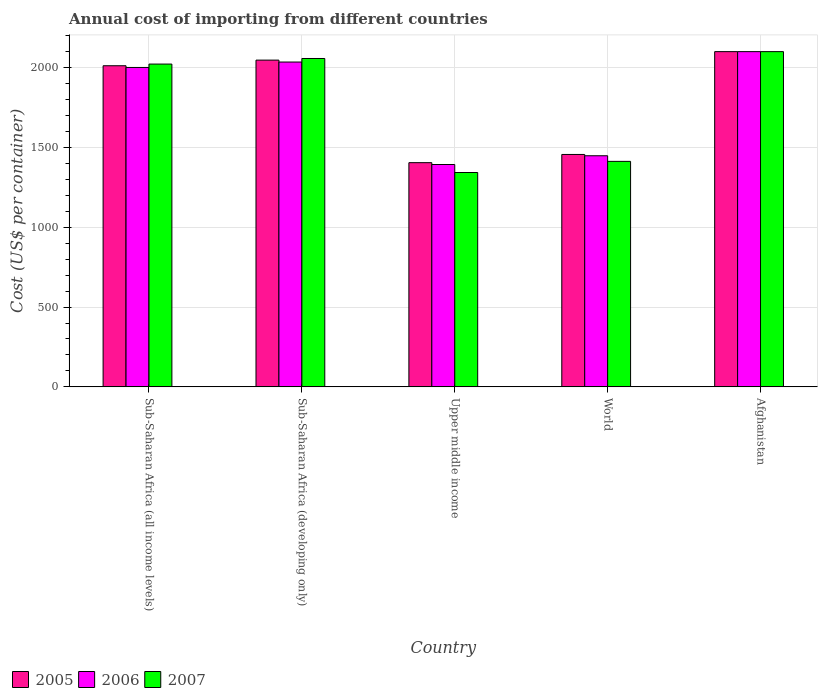How many different coloured bars are there?
Provide a succinct answer. 3. How many groups of bars are there?
Keep it short and to the point. 5. How many bars are there on the 3rd tick from the left?
Offer a terse response. 3. How many bars are there on the 3rd tick from the right?
Your answer should be very brief. 3. What is the label of the 4th group of bars from the left?
Provide a succinct answer. World. In how many cases, is the number of bars for a given country not equal to the number of legend labels?
Offer a very short reply. 0. What is the total annual cost of importing in 2006 in Afghanistan?
Provide a short and direct response. 2100. Across all countries, what is the maximum total annual cost of importing in 2007?
Your response must be concise. 2100. Across all countries, what is the minimum total annual cost of importing in 2007?
Make the answer very short. 1342.85. In which country was the total annual cost of importing in 2007 maximum?
Offer a very short reply. Afghanistan. In which country was the total annual cost of importing in 2007 minimum?
Your answer should be compact. Upper middle income. What is the total total annual cost of importing in 2005 in the graph?
Your answer should be compact. 9018.91. What is the difference between the total annual cost of importing in 2006 in Sub-Saharan Africa (all income levels) and that in World?
Provide a short and direct response. 553.13. What is the difference between the total annual cost of importing in 2007 in World and the total annual cost of importing in 2005 in Sub-Saharan Africa (all income levels)?
Offer a terse response. -599.03. What is the average total annual cost of importing in 2006 per country?
Ensure brevity in your answer.  1795.28. What is the difference between the total annual cost of importing of/in 2007 and total annual cost of importing of/in 2005 in Sub-Saharan Africa (developing only)?
Your response must be concise. 10.16. What is the ratio of the total annual cost of importing in 2007 in Sub-Saharan Africa (developing only) to that in World?
Offer a terse response. 1.46. Is the total annual cost of importing in 2007 in Sub-Saharan Africa (developing only) less than that in World?
Provide a succinct answer. No. Is the difference between the total annual cost of importing in 2007 in Sub-Saharan Africa (all income levels) and Upper middle income greater than the difference between the total annual cost of importing in 2005 in Sub-Saharan Africa (all income levels) and Upper middle income?
Keep it short and to the point. Yes. What is the difference between the highest and the second highest total annual cost of importing in 2007?
Keep it short and to the point. -42.93. What is the difference between the highest and the lowest total annual cost of importing in 2005?
Make the answer very short. 695.49. Is the sum of the total annual cost of importing in 2005 in Afghanistan and Sub-Saharan Africa (all income levels) greater than the maximum total annual cost of importing in 2007 across all countries?
Your answer should be very brief. Yes. What does the 2nd bar from the right in Upper middle income represents?
Ensure brevity in your answer.  2006. How many bars are there?
Provide a short and direct response. 15. Are all the bars in the graph horizontal?
Your answer should be very brief. No. Does the graph contain grids?
Offer a terse response. Yes. Where does the legend appear in the graph?
Give a very brief answer. Bottom left. How many legend labels are there?
Make the answer very short. 3. How are the legend labels stacked?
Your answer should be very brief. Horizontal. What is the title of the graph?
Your answer should be very brief. Annual cost of importing from different countries. Does "2007" appear as one of the legend labels in the graph?
Your answer should be compact. Yes. What is the label or title of the Y-axis?
Offer a terse response. Cost (US$ per container). What is the Cost (US$ per container) of 2005 in Sub-Saharan Africa (all income levels)?
Your answer should be very brief. 2011.64. What is the Cost (US$ per container) of 2006 in Sub-Saharan Africa (all income levels)?
Your answer should be very brief. 2000.87. What is the Cost (US$ per container) in 2007 in Sub-Saharan Africa (all income levels)?
Make the answer very short. 2022.13. What is the Cost (US$ per container) in 2005 in Sub-Saharan Africa (developing only)?
Offer a very short reply. 2046.91. What is the Cost (US$ per container) of 2006 in Sub-Saharan Africa (developing only)?
Ensure brevity in your answer.  2034.84. What is the Cost (US$ per container) of 2007 in Sub-Saharan Africa (developing only)?
Make the answer very short. 2057.07. What is the Cost (US$ per container) of 2005 in Upper middle income?
Keep it short and to the point. 1404.51. What is the Cost (US$ per container) in 2006 in Upper middle income?
Keep it short and to the point. 1392.96. What is the Cost (US$ per container) in 2007 in Upper middle income?
Your answer should be compact. 1342.85. What is the Cost (US$ per container) in 2005 in World?
Keep it short and to the point. 1455.85. What is the Cost (US$ per container) in 2006 in World?
Provide a short and direct response. 1447.74. What is the Cost (US$ per container) in 2007 in World?
Keep it short and to the point. 1412.62. What is the Cost (US$ per container) in 2005 in Afghanistan?
Offer a terse response. 2100. What is the Cost (US$ per container) in 2006 in Afghanistan?
Offer a very short reply. 2100. What is the Cost (US$ per container) in 2007 in Afghanistan?
Your answer should be very brief. 2100. Across all countries, what is the maximum Cost (US$ per container) in 2005?
Offer a terse response. 2100. Across all countries, what is the maximum Cost (US$ per container) of 2006?
Keep it short and to the point. 2100. Across all countries, what is the maximum Cost (US$ per container) in 2007?
Make the answer very short. 2100. Across all countries, what is the minimum Cost (US$ per container) in 2005?
Provide a succinct answer. 1404.51. Across all countries, what is the minimum Cost (US$ per container) in 2006?
Ensure brevity in your answer.  1392.96. Across all countries, what is the minimum Cost (US$ per container) of 2007?
Your answer should be very brief. 1342.85. What is the total Cost (US$ per container) in 2005 in the graph?
Keep it short and to the point. 9018.91. What is the total Cost (US$ per container) of 2006 in the graph?
Your answer should be compact. 8976.41. What is the total Cost (US$ per container) in 2007 in the graph?
Your answer should be compact. 8934.67. What is the difference between the Cost (US$ per container) of 2005 in Sub-Saharan Africa (all income levels) and that in Sub-Saharan Africa (developing only)?
Your answer should be compact. -35.26. What is the difference between the Cost (US$ per container) in 2006 in Sub-Saharan Africa (all income levels) and that in Sub-Saharan Africa (developing only)?
Your answer should be very brief. -33.97. What is the difference between the Cost (US$ per container) of 2007 in Sub-Saharan Africa (all income levels) and that in Sub-Saharan Africa (developing only)?
Keep it short and to the point. -34.94. What is the difference between the Cost (US$ per container) in 2005 in Sub-Saharan Africa (all income levels) and that in Upper middle income?
Provide a succinct answer. 607.13. What is the difference between the Cost (US$ per container) in 2006 in Sub-Saharan Africa (all income levels) and that in Upper middle income?
Your answer should be very brief. 607.91. What is the difference between the Cost (US$ per container) of 2007 in Sub-Saharan Africa (all income levels) and that in Upper middle income?
Your answer should be compact. 679.28. What is the difference between the Cost (US$ per container) in 2005 in Sub-Saharan Africa (all income levels) and that in World?
Your answer should be compact. 555.79. What is the difference between the Cost (US$ per container) in 2006 in Sub-Saharan Africa (all income levels) and that in World?
Provide a short and direct response. 553.13. What is the difference between the Cost (US$ per container) of 2007 in Sub-Saharan Africa (all income levels) and that in World?
Your answer should be very brief. 609.51. What is the difference between the Cost (US$ per container) in 2005 in Sub-Saharan Africa (all income levels) and that in Afghanistan?
Provide a short and direct response. -88.36. What is the difference between the Cost (US$ per container) in 2006 in Sub-Saharan Africa (all income levels) and that in Afghanistan?
Offer a very short reply. -99.13. What is the difference between the Cost (US$ per container) of 2007 in Sub-Saharan Africa (all income levels) and that in Afghanistan?
Provide a short and direct response. -77.87. What is the difference between the Cost (US$ per container) in 2005 in Sub-Saharan Africa (developing only) and that in Upper middle income?
Your answer should be compact. 642.4. What is the difference between the Cost (US$ per container) of 2006 in Sub-Saharan Africa (developing only) and that in Upper middle income?
Make the answer very short. 641.88. What is the difference between the Cost (US$ per container) in 2007 in Sub-Saharan Africa (developing only) and that in Upper middle income?
Make the answer very short. 714.21. What is the difference between the Cost (US$ per container) in 2005 in Sub-Saharan Africa (developing only) and that in World?
Provide a short and direct response. 591.06. What is the difference between the Cost (US$ per container) in 2006 in Sub-Saharan Africa (developing only) and that in World?
Your answer should be compact. 587.1. What is the difference between the Cost (US$ per container) in 2007 in Sub-Saharan Africa (developing only) and that in World?
Make the answer very short. 644.45. What is the difference between the Cost (US$ per container) in 2005 in Sub-Saharan Africa (developing only) and that in Afghanistan?
Offer a terse response. -53.09. What is the difference between the Cost (US$ per container) of 2006 in Sub-Saharan Africa (developing only) and that in Afghanistan?
Provide a short and direct response. -65.16. What is the difference between the Cost (US$ per container) of 2007 in Sub-Saharan Africa (developing only) and that in Afghanistan?
Ensure brevity in your answer.  -42.93. What is the difference between the Cost (US$ per container) in 2005 in Upper middle income and that in World?
Ensure brevity in your answer.  -51.34. What is the difference between the Cost (US$ per container) in 2006 in Upper middle income and that in World?
Ensure brevity in your answer.  -54.78. What is the difference between the Cost (US$ per container) in 2007 in Upper middle income and that in World?
Ensure brevity in your answer.  -69.76. What is the difference between the Cost (US$ per container) of 2005 in Upper middle income and that in Afghanistan?
Offer a terse response. -695.49. What is the difference between the Cost (US$ per container) of 2006 in Upper middle income and that in Afghanistan?
Offer a terse response. -707.04. What is the difference between the Cost (US$ per container) in 2007 in Upper middle income and that in Afghanistan?
Offer a very short reply. -757.15. What is the difference between the Cost (US$ per container) of 2005 in World and that in Afghanistan?
Give a very brief answer. -644.15. What is the difference between the Cost (US$ per container) of 2006 in World and that in Afghanistan?
Offer a very short reply. -652.26. What is the difference between the Cost (US$ per container) in 2007 in World and that in Afghanistan?
Offer a terse response. -687.38. What is the difference between the Cost (US$ per container) of 2005 in Sub-Saharan Africa (all income levels) and the Cost (US$ per container) of 2006 in Sub-Saharan Africa (developing only)?
Your answer should be compact. -23.2. What is the difference between the Cost (US$ per container) in 2005 in Sub-Saharan Africa (all income levels) and the Cost (US$ per container) in 2007 in Sub-Saharan Africa (developing only)?
Your response must be concise. -45.42. What is the difference between the Cost (US$ per container) of 2006 in Sub-Saharan Africa (all income levels) and the Cost (US$ per container) of 2007 in Sub-Saharan Africa (developing only)?
Make the answer very short. -56.2. What is the difference between the Cost (US$ per container) of 2005 in Sub-Saharan Africa (all income levels) and the Cost (US$ per container) of 2006 in Upper middle income?
Make the answer very short. 618.69. What is the difference between the Cost (US$ per container) in 2005 in Sub-Saharan Africa (all income levels) and the Cost (US$ per container) in 2007 in Upper middle income?
Give a very brief answer. 668.79. What is the difference between the Cost (US$ per container) in 2006 in Sub-Saharan Africa (all income levels) and the Cost (US$ per container) in 2007 in Upper middle income?
Offer a very short reply. 658.02. What is the difference between the Cost (US$ per container) of 2005 in Sub-Saharan Africa (all income levels) and the Cost (US$ per container) of 2006 in World?
Keep it short and to the point. 563.9. What is the difference between the Cost (US$ per container) of 2005 in Sub-Saharan Africa (all income levels) and the Cost (US$ per container) of 2007 in World?
Ensure brevity in your answer.  599.03. What is the difference between the Cost (US$ per container) of 2006 in Sub-Saharan Africa (all income levels) and the Cost (US$ per container) of 2007 in World?
Make the answer very short. 588.25. What is the difference between the Cost (US$ per container) in 2005 in Sub-Saharan Africa (all income levels) and the Cost (US$ per container) in 2006 in Afghanistan?
Give a very brief answer. -88.36. What is the difference between the Cost (US$ per container) of 2005 in Sub-Saharan Africa (all income levels) and the Cost (US$ per container) of 2007 in Afghanistan?
Offer a terse response. -88.36. What is the difference between the Cost (US$ per container) of 2006 in Sub-Saharan Africa (all income levels) and the Cost (US$ per container) of 2007 in Afghanistan?
Provide a succinct answer. -99.13. What is the difference between the Cost (US$ per container) of 2005 in Sub-Saharan Africa (developing only) and the Cost (US$ per container) of 2006 in Upper middle income?
Give a very brief answer. 653.95. What is the difference between the Cost (US$ per container) of 2005 in Sub-Saharan Africa (developing only) and the Cost (US$ per container) of 2007 in Upper middle income?
Provide a succinct answer. 704.05. What is the difference between the Cost (US$ per container) in 2006 in Sub-Saharan Africa (developing only) and the Cost (US$ per container) in 2007 in Upper middle income?
Make the answer very short. 691.99. What is the difference between the Cost (US$ per container) of 2005 in Sub-Saharan Africa (developing only) and the Cost (US$ per container) of 2006 in World?
Your response must be concise. 599.17. What is the difference between the Cost (US$ per container) in 2005 in Sub-Saharan Africa (developing only) and the Cost (US$ per container) in 2007 in World?
Make the answer very short. 634.29. What is the difference between the Cost (US$ per container) of 2006 in Sub-Saharan Africa (developing only) and the Cost (US$ per container) of 2007 in World?
Offer a very short reply. 622.22. What is the difference between the Cost (US$ per container) in 2005 in Sub-Saharan Africa (developing only) and the Cost (US$ per container) in 2006 in Afghanistan?
Your answer should be very brief. -53.09. What is the difference between the Cost (US$ per container) in 2005 in Sub-Saharan Africa (developing only) and the Cost (US$ per container) in 2007 in Afghanistan?
Make the answer very short. -53.09. What is the difference between the Cost (US$ per container) of 2006 in Sub-Saharan Africa (developing only) and the Cost (US$ per container) of 2007 in Afghanistan?
Your answer should be compact. -65.16. What is the difference between the Cost (US$ per container) of 2005 in Upper middle income and the Cost (US$ per container) of 2006 in World?
Your answer should be compact. -43.23. What is the difference between the Cost (US$ per container) of 2005 in Upper middle income and the Cost (US$ per container) of 2007 in World?
Your response must be concise. -8.11. What is the difference between the Cost (US$ per container) in 2006 in Upper middle income and the Cost (US$ per container) in 2007 in World?
Keep it short and to the point. -19.66. What is the difference between the Cost (US$ per container) in 2005 in Upper middle income and the Cost (US$ per container) in 2006 in Afghanistan?
Offer a terse response. -695.49. What is the difference between the Cost (US$ per container) of 2005 in Upper middle income and the Cost (US$ per container) of 2007 in Afghanistan?
Offer a very short reply. -695.49. What is the difference between the Cost (US$ per container) in 2006 in Upper middle income and the Cost (US$ per container) in 2007 in Afghanistan?
Keep it short and to the point. -707.04. What is the difference between the Cost (US$ per container) in 2005 in World and the Cost (US$ per container) in 2006 in Afghanistan?
Your answer should be very brief. -644.15. What is the difference between the Cost (US$ per container) of 2005 in World and the Cost (US$ per container) of 2007 in Afghanistan?
Offer a terse response. -644.15. What is the difference between the Cost (US$ per container) of 2006 in World and the Cost (US$ per container) of 2007 in Afghanistan?
Your answer should be compact. -652.26. What is the average Cost (US$ per container) in 2005 per country?
Offer a terse response. 1803.78. What is the average Cost (US$ per container) of 2006 per country?
Your answer should be very brief. 1795.28. What is the average Cost (US$ per container) in 2007 per country?
Keep it short and to the point. 1786.93. What is the difference between the Cost (US$ per container) in 2005 and Cost (US$ per container) in 2006 in Sub-Saharan Africa (all income levels)?
Offer a very short reply. 10.77. What is the difference between the Cost (US$ per container) of 2005 and Cost (US$ per container) of 2007 in Sub-Saharan Africa (all income levels)?
Give a very brief answer. -10.49. What is the difference between the Cost (US$ per container) in 2006 and Cost (US$ per container) in 2007 in Sub-Saharan Africa (all income levels)?
Offer a very short reply. -21.26. What is the difference between the Cost (US$ per container) of 2005 and Cost (US$ per container) of 2006 in Sub-Saharan Africa (developing only)?
Your answer should be compact. 12.07. What is the difference between the Cost (US$ per container) of 2005 and Cost (US$ per container) of 2007 in Sub-Saharan Africa (developing only)?
Make the answer very short. -10.16. What is the difference between the Cost (US$ per container) in 2006 and Cost (US$ per container) in 2007 in Sub-Saharan Africa (developing only)?
Provide a short and direct response. -22.23. What is the difference between the Cost (US$ per container) of 2005 and Cost (US$ per container) of 2006 in Upper middle income?
Keep it short and to the point. 11.55. What is the difference between the Cost (US$ per container) in 2005 and Cost (US$ per container) in 2007 in Upper middle income?
Provide a short and direct response. 61.66. What is the difference between the Cost (US$ per container) in 2006 and Cost (US$ per container) in 2007 in Upper middle income?
Your answer should be compact. 50.1. What is the difference between the Cost (US$ per container) of 2005 and Cost (US$ per container) of 2006 in World?
Provide a short and direct response. 8.11. What is the difference between the Cost (US$ per container) in 2005 and Cost (US$ per container) in 2007 in World?
Make the answer very short. 43.23. What is the difference between the Cost (US$ per container) of 2006 and Cost (US$ per container) of 2007 in World?
Your answer should be very brief. 35.12. What is the difference between the Cost (US$ per container) of 2005 and Cost (US$ per container) of 2006 in Afghanistan?
Your response must be concise. 0. What is the difference between the Cost (US$ per container) of 2006 and Cost (US$ per container) of 2007 in Afghanistan?
Your answer should be very brief. 0. What is the ratio of the Cost (US$ per container) of 2005 in Sub-Saharan Africa (all income levels) to that in Sub-Saharan Africa (developing only)?
Provide a succinct answer. 0.98. What is the ratio of the Cost (US$ per container) of 2006 in Sub-Saharan Africa (all income levels) to that in Sub-Saharan Africa (developing only)?
Make the answer very short. 0.98. What is the ratio of the Cost (US$ per container) of 2007 in Sub-Saharan Africa (all income levels) to that in Sub-Saharan Africa (developing only)?
Give a very brief answer. 0.98. What is the ratio of the Cost (US$ per container) of 2005 in Sub-Saharan Africa (all income levels) to that in Upper middle income?
Your answer should be compact. 1.43. What is the ratio of the Cost (US$ per container) of 2006 in Sub-Saharan Africa (all income levels) to that in Upper middle income?
Ensure brevity in your answer.  1.44. What is the ratio of the Cost (US$ per container) of 2007 in Sub-Saharan Africa (all income levels) to that in Upper middle income?
Provide a short and direct response. 1.51. What is the ratio of the Cost (US$ per container) of 2005 in Sub-Saharan Africa (all income levels) to that in World?
Offer a terse response. 1.38. What is the ratio of the Cost (US$ per container) in 2006 in Sub-Saharan Africa (all income levels) to that in World?
Offer a very short reply. 1.38. What is the ratio of the Cost (US$ per container) of 2007 in Sub-Saharan Africa (all income levels) to that in World?
Provide a short and direct response. 1.43. What is the ratio of the Cost (US$ per container) in 2005 in Sub-Saharan Africa (all income levels) to that in Afghanistan?
Give a very brief answer. 0.96. What is the ratio of the Cost (US$ per container) of 2006 in Sub-Saharan Africa (all income levels) to that in Afghanistan?
Your answer should be very brief. 0.95. What is the ratio of the Cost (US$ per container) of 2007 in Sub-Saharan Africa (all income levels) to that in Afghanistan?
Ensure brevity in your answer.  0.96. What is the ratio of the Cost (US$ per container) of 2005 in Sub-Saharan Africa (developing only) to that in Upper middle income?
Keep it short and to the point. 1.46. What is the ratio of the Cost (US$ per container) of 2006 in Sub-Saharan Africa (developing only) to that in Upper middle income?
Offer a terse response. 1.46. What is the ratio of the Cost (US$ per container) of 2007 in Sub-Saharan Africa (developing only) to that in Upper middle income?
Ensure brevity in your answer.  1.53. What is the ratio of the Cost (US$ per container) in 2005 in Sub-Saharan Africa (developing only) to that in World?
Offer a terse response. 1.41. What is the ratio of the Cost (US$ per container) in 2006 in Sub-Saharan Africa (developing only) to that in World?
Provide a short and direct response. 1.41. What is the ratio of the Cost (US$ per container) of 2007 in Sub-Saharan Africa (developing only) to that in World?
Your answer should be compact. 1.46. What is the ratio of the Cost (US$ per container) of 2005 in Sub-Saharan Africa (developing only) to that in Afghanistan?
Offer a terse response. 0.97. What is the ratio of the Cost (US$ per container) in 2006 in Sub-Saharan Africa (developing only) to that in Afghanistan?
Your answer should be compact. 0.97. What is the ratio of the Cost (US$ per container) in 2007 in Sub-Saharan Africa (developing only) to that in Afghanistan?
Your answer should be compact. 0.98. What is the ratio of the Cost (US$ per container) in 2005 in Upper middle income to that in World?
Give a very brief answer. 0.96. What is the ratio of the Cost (US$ per container) of 2006 in Upper middle income to that in World?
Your answer should be compact. 0.96. What is the ratio of the Cost (US$ per container) of 2007 in Upper middle income to that in World?
Your answer should be compact. 0.95. What is the ratio of the Cost (US$ per container) of 2005 in Upper middle income to that in Afghanistan?
Your answer should be very brief. 0.67. What is the ratio of the Cost (US$ per container) in 2006 in Upper middle income to that in Afghanistan?
Provide a succinct answer. 0.66. What is the ratio of the Cost (US$ per container) of 2007 in Upper middle income to that in Afghanistan?
Offer a terse response. 0.64. What is the ratio of the Cost (US$ per container) in 2005 in World to that in Afghanistan?
Ensure brevity in your answer.  0.69. What is the ratio of the Cost (US$ per container) in 2006 in World to that in Afghanistan?
Your answer should be compact. 0.69. What is the ratio of the Cost (US$ per container) of 2007 in World to that in Afghanistan?
Provide a succinct answer. 0.67. What is the difference between the highest and the second highest Cost (US$ per container) of 2005?
Ensure brevity in your answer.  53.09. What is the difference between the highest and the second highest Cost (US$ per container) of 2006?
Provide a short and direct response. 65.16. What is the difference between the highest and the second highest Cost (US$ per container) in 2007?
Make the answer very short. 42.93. What is the difference between the highest and the lowest Cost (US$ per container) in 2005?
Your answer should be very brief. 695.49. What is the difference between the highest and the lowest Cost (US$ per container) in 2006?
Provide a succinct answer. 707.04. What is the difference between the highest and the lowest Cost (US$ per container) of 2007?
Offer a terse response. 757.15. 